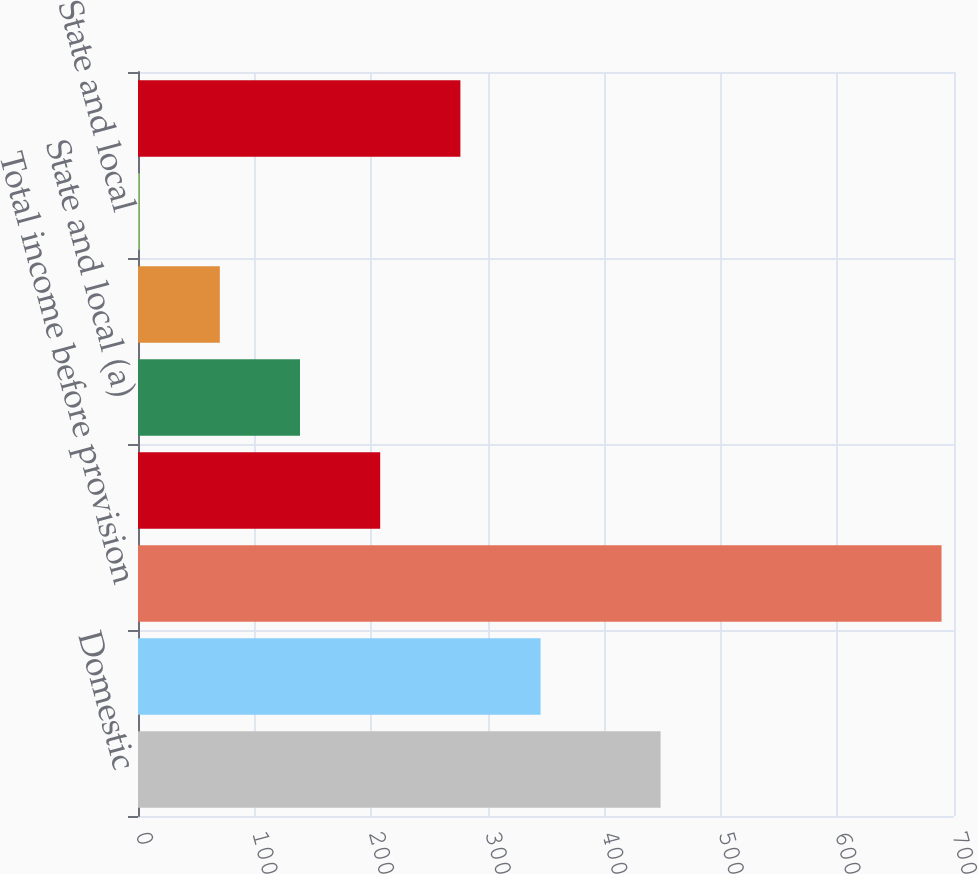<chart> <loc_0><loc_0><loc_500><loc_500><bar_chart><fcel>Domestic<fcel>Foreign<fcel>Total income before provision<fcel>Federal (a)<fcel>State and local (a)<fcel>Federal<fcel>State and local<fcel>Total provision for income<nl><fcel>448.3<fcel>345.35<fcel>689.3<fcel>207.77<fcel>138.98<fcel>70.19<fcel>1.4<fcel>276.56<nl></chart> 